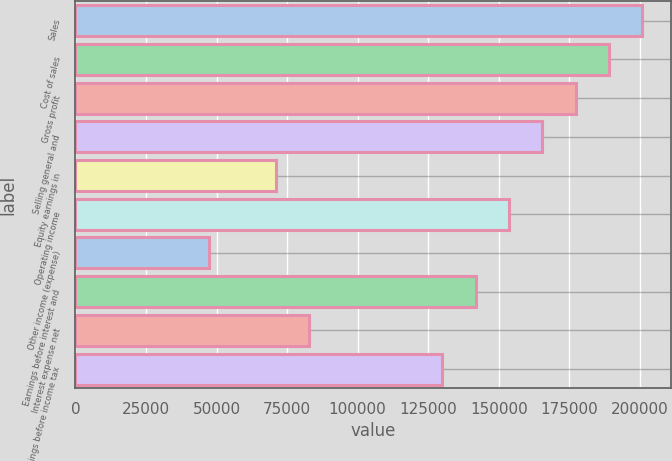Convert chart. <chart><loc_0><loc_0><loc_500><loc_500><bar_chart><fcel>Sales<fcel>Cost of sales<fcel>Gross profit<fcel>Selling general and<fcel>Equity earnings in<fcel>Operating income<fcel>Other income (expense)<fcel>Earnings before interest and<fcel>Interest expense net<fcel>Earnings before income tax<nl><fcel>200963<fcel>189142<fcel>177320<fcel>165499<fcel>70929<fcel>153678<fcel>47286.5<fcel>141857<fcel>82750.3<fcel>130035<nl></chart> 